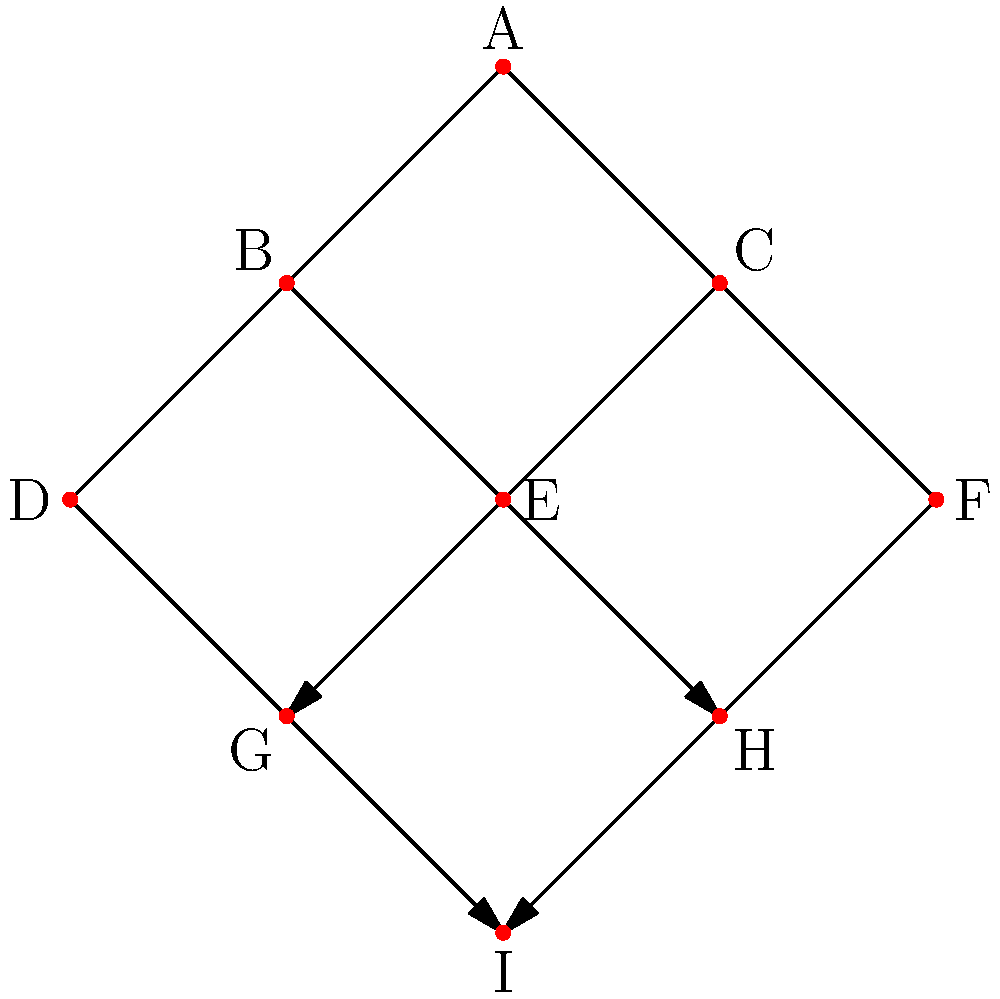Consider the directed graph representing a hierarchical social structure, where each node represents a social class and arrows indicate influence or authority. How many non-trivial automorphisms does this graph have, and what do they represent in terms of maintaining traditional social hierarchies? To determine the number of non-trivial automorphisms and their significance:

1. Analyze the graph structure:
   - Node A is at the top (unique position)
   - Nodes B and C are at the second level
   - Nodes D, E, and F are at the third level
   - Nodes G and H are at the fourth level
   - Node I is at the bottom (unique position)

2. Identify symmetries:
   - The graph is symmetrical along a vertical axis
   - Nodes B and C can be swapped
   - Nodes D and F can be swapped
   - Nodes G and H can be swapped

3. Count non-trivial automorphisms:
   - Swapping B and C
   - Swapping D and F
   - Swapping G and H
   - Swapping both (B,C) and (G,H)
   - Swapping both (B,C) and (D,F)
   - Swapping both (D,F) and (G,H)
   - Swapping all three pairs (B,C), (D,F), and (G,H)

4. Interpret the automorphisms:
   - These automorphisms represent ways to rearrange the social structure while maintaining the overall hierarchy
   - They show that certain positions in the hierarchy are interchangeable, preserving traditional power dynamics

5. Significance for traditional values:
   - The automorphisms demonstrate the stability of the hierarchical structure
   - They reinforce the idea that specific roles in society are fixed and can be filled by different individuals without altering the overall social order
Answer: 7 non-trivial automorphisms, representing interchangeable positions within a stable hierarchical structure 